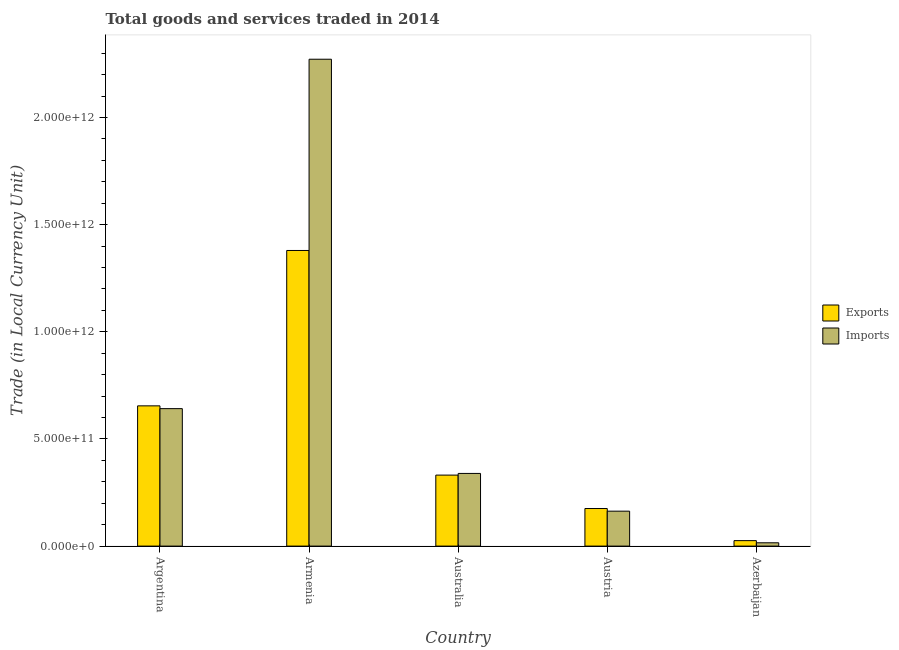How many groups of bars are there?
Ensure brevity in your answer.  5. Are the number of bars on each tick of the X-axis equal?
Keep it short and to the point. Yes. How many bars are there on the 3rd tick from the left?
Offer a terse response. 2. What is the label of the 2nd group of bars from the left?
Provide a succinct answer. Armenia. In how many cases, is the number of bars for a given country not equal to the number of legend labels?
Offer a very short reply. 0. What is the export of goods and services in Azerbaijan?
Your response must be concise. 2.55e+1. Across all countries, what is the maximum export of goods and services?
Your response must be concise. 1.38e+12. Across all countries, what is the minimum export of goods and services?
Your answer should be very brief. 2.55e+1. In which country was the imports of goods and services maximum?
Your answer should be very brief. Armenia. In which country was the export of goods and services minimum?
Your answer should be compact. Azerbaijan. What is the total imports of goods and services in the graph?
Provide a short and direct response. 3.43e+12. What is the difference between the export of goods and services in Armenia and that in Australia?
Your response must be concise. 1.05e+12. What is the difference between the export of goods and services in Australia and the imports of goods and services in Armenia?
Your answer should be very brief. -1.94e+12. What is the average imports of goods and services per country?
Ensure brevity in your answer.  6.86e+11. What is the difference between the export of goods and services and imports of goods and services in Argentina?
Offer a terse response. 1.30e+1. In how many countries, is the export of goods and services greater than 1500000000000 LCU?
Offer a terse response. 0. What is the ratio of the imports of goods and services in Armenia to that in Austria?
Provide a short and direct response. 13.94. Is the difference between the export of goods and services in Argentina and Australia greater than the difference between the imports of goods and services in Argentina and Australia?
Provide a short and direct response. Yes. What is the difference between the highest and the second highest export of goods and services?
Give a very brief answer. 7.25e+11. What is the difference between the highest and the lowest imports of goods and services?
Make the answer very short. 2.26e+12. In how many countries, is the imports of goods and services greater than the average imports of goods and services taken over all countries?
Make the answer very short. 1. What does the 2nd bar from the left in Australia represents?
Offer a terse response. Imports. What does the 1st bar from the right in Azerbaijan represents?
Give a very brief answer. Imports. How many countries are there in the graph?
Offer a terse response. 5. What is the difference between two consecutive major ticks on the Y-axis?
Offer a very short reply. 5.00e+11. Does the graph contain any zero values?
Provide a succinct answer. No. Does the graph contain grids?
Offer a terse response. No. Where does the legend appear in the graph?
Your response must be concise. Center right. What is the title of the graph?
Offer a terse response. Total goods and services traded in 2014. Does "% of GNI" appear as one of the legend labels in the graph?
Your answer should be very brief. No. What is the label or title of the X-axis?
Your answer should be very brief. Country. What is the label or title of the Y-axis?
Keep it short and to the point. Trade (in Local Currency Unit). What is the Trade (in Local Currency Unit) of Exports in Argentina?
Provide a short and direct response. 6.54e+11. What is the Trade (in Local Currency Unit) of Imports in Argentina?
Your answer should be very brief. 6.41e+11. What is the Trade (in Local Currency Unit) in Exports in Armenia?
Offer a very short reply. 1.38e+12. What is the Trade (in Local Currency Unit) of Imports in Armenia?
Your answer should be very brief. 2.27e+12. What is the Trade (in Local Currency Unit) in Exports in Australia?
Keep it short and to the point. 3.31e+11. What is the Trade (in Local Currency Unit) of Imports in Australia?
Your response must be concise. 3.39e+11. What is the Trade (in Local Currency Unit) of Exports in Austria?
Provide a short and direct response. 1.75e+11. What is the Trade (in Local Currency Unit) of Imports in Austria?
Ensure brevity in your answer.  1.63e+11. What is the Trade (in Local Currency Unit) in Exports in Azerbaijan?
Your answer should be very brief. 2.55e+1. What is the Trade (in Local Currency Unit) in Imports in Azerbaijan?
Your answer should be very brief. 1.55e+1. Across all countries, what is the maximum Trade (in Local Currency Unit) of Exports?
Offer a terse response. 1.38e+12. Across all countries, what is the maximum Trade (in Local Currency Unit) of Imports?
Keep it short and to the point. 2.27e+12. Across all countries, what is the minimum Trade (in Local Currency Unit) in Exports?
Your answer should be compact. 2.55e+1. Across all countries, what is the minimum Trade (in Local Currency Unit) in Imports?
Offer a very short reply. 1.55e+1. What is the total Trade (in Local Currency Unit) of Exports in the graph?
Offer a very short reply. 2.57e+12. What is the total Trade (in Local Currency Unit) of Imports in the graph?
Your response must be concise. 3.43e+12. What is the difference between the Trade (in Local Currency Unit) in Exports in Argentina and that in Armenia?
Provide a succinct answer. -7.25e+11. What is the difference between the Trade (in Local Currency Unit) in Imports in Argentina and that in Armenia?
Make the answer very short. -1.63e+12. What is the difference between the Trade (in Local Currency Unit) in Exports in Argentina and that in Australia?
Your answer should be very brief. 3.23e+11. What is the difference between the Trade (in Local Currency Unit) of Imports in Argentina and that in Australia?
Your answer should be very brief. 3.02e+11. What is the difference between the Trade (in Local Currency Unit) of Exports in Argentina and that in Austria?
Offer a terse response. 4.79e+11. What is the difference between the Trade (in Local Currency Unit) of Imports in Argentina and that in Austria?
Give a very brief answer. 4.78e+11. What is the difference between the Trade (in Local Currency Unit) of Exports in Argentina and that in Azerbaijan?
Keep it short and to the point. 6.29e+11. What is the difference between the Trade (in Local Currency Unit) of Imports in Argentina and that in Azerbaijan?
Provide a short and direct response. 6.26e+11. What is the difference between the Trade (in Local Currency Unit) of Exports in Armenia and that in Australia?
Give a very brief answer. 1.05e+12. What is the difference between the Trade (in Local Currency Unit) of Imports in Armenia and that in Australia?
Your answer should be very brief. 1.93e+12. What is the difference between the Trade (in Local Currency Unit) of Exports in Armenia and that in Austria?
Make the answer very short. 1.20e+12. What is the difference between the Trade (in Local Currency Unit) in Imports in Armenia and that in Austria?
Your answer should be compact. 2.11e+12. What is the difference between the Trade (in Local Currency Unit) in Exports in Armenia and that in Azerbaijan?
Offer a very short reply. 1.35e+12. What is the difference between the Trade (in Local Currency Unit) in Imports in Armenia and that in Azerbaijan?
Offer a terse response. 2.26e+12. What is the difference between the Trade (in Local Currency Unit) of Exports in Australia and that in Austria?
Your answer should be compact. 1.56e+11. What is the difference between the Trade (in Local Currency Unit) of Imports in Australia and that in Austria?
Provide a succinct answer. 1.76e+11. What is the difference between the Trade (in Local Currency Unit) in Exports in Australia and that in Azerbaijan?
Keep it short and to the point. 3.06e+11. What is the difference between the Trade (in Local Currency Unit) in Imports in Australia and that in Azerbaijan?
Keep it short and to the point. 3.24e+11. What is the difference between the Trade (in Local Currency Unit) in Exports in Austria and that in Azerbaijan?
Your answer should be compact. 1.50e+11. What is the difference between the Trade (in Local Currency Unit) in Imports in Austria and that in Azerbaijan?
Make the answer very short. 1.48e+11. What is the difference between the Trade (in Local Currency Unit) in Exports in Argentina and the Trade (in Local Currency Unit) in Imports in Armenia?
Give a very brief answer. -1.62e+12. What is the difference between the Trade (in Local Currency Unit) of Exports in Argentina and the Trade (in Local Currency Unit) of Imports in Australia?
Your answer should be very brief. 3.15e+11. What is the difference between the Trade (in Local Currency Unit) in Exports in Argentina and the Trade (in Local Currency Unit) in Imports in Austria?
Your answer should be compact. 4.91e+11. What is the difference between the Trade (in Local Currency Unit) in Exports in Argentina and the Trade (in Local Currency Unit) in Imports in Azerbaijan?
Offer a terse response. 6.39e+11. What is the difference between the Trade (in Local Currency Unit) of Exports in Armenia and the Trade (in Local Currency Unit) of Imports in Australia?
Give a very brief answer. 1.04e+12. What is the difference between the Trade (in Local Currency Unit) in Exports in Armenia and the Trade (in Local Currency Unit) in Imports in Austria?
Your response must be concise. 1.22e+12. What is the difference between the Trade (in Local Currency Unit) in Exports in Armenia and the Trade (in Local Currency Unit) in Imports in Azerbaijan?
Keep it short and to the point. 1.36e+12. What is the difference between the Trade (in Local Currency Unit) of Exports in Australia and the Trade (in Local Currency Unit) of Imports in Austria?
Your answer should be very brief. 1.68e+11. What is the difference between the Trade (in Local Currency Unit) of Exports in Australia and the Trade (in Local Currency Unit) of Imports in Azerbaijan?
Your answer should be compact. 3.16e+11. What is the difference between the Trade (in Local Currency Unit) in Exports in Austria and the Trade (in Local Currency Unit) in Imports in Azerbaijan?
Make the answer very short. 1.60e+11. What is the average Trade (in Local Currency Unit) of Exports per country?
Give a very brief answer. 5.13e+11. What is the average Trade (in Local Currency Unit) in Imports per country?
Make the answer very short. 6.86e+11. What is the difference between the Trade (in Local Currency Unit) of Exports and Trade (in Local Currency Unit) of Imports in Argentina?
Your answer should be very brief. 1.30e+1. What is the difference between the Trade (in Local Currency Unit) in Exports and Trade (in Local Currency Unit) in Imports in Armenia?
Offer a terse response. -8.92e+11. What is the difference between the Trade (in Local Currency Unit) of Exports and Trade (in Local Currency Unit) of Imports in Australia?
Provide a succinct answer. -7.82e+09. What is the difference between the Trade (in Local Currency Unit) in Exports and Trade (in Local Currency Unit) in Imports in Austria?
Provide a succinct answer. 1.24e+1. What is the difference between the Trade (in Local Currency Unit) of Exports and Trade (in Local Currency Unit) of Imports in Azerbaijan?
Your answer should be very brief. 1.01e+1. What is the ratio of the Trade (in Local Currency Unit) of Exports in Argentina to that in Armenia?
Give a very brief answer. 0.47. What is the ratio of the Trade (in Local Currency Unit) of Imports in Argentina to that in Armenia?
Offer a terse response. 0.28. What is the ratio of the Trade (in Local Currency Unit) in Exports in Argentina to that in Australia?
Your response must be concise. 1.98. What is the ratio of the Trade (in Local Currency Unit) in Imports in Argentina to that in Australia?
Make the answer very short. 1.89. What is the ratio of the Trade (in Local Currency Unit) in Exports in Argentina to that in Austria?
Offer a terse response. 3.73. What is the ratio of the Trade (in Local Currency Unit) of Imports in Argentina to that in Austria?
Offer a very short reply. 3.94. What is the ratio of the Trade (in Local Currency Unit) of Exports in Argentina to that in Azerbaijan?
Your answer should be compact. 25.63. What is the ratio of the Trade (in Local Currency Unit) in Imports in Argentina to that in Azerbaijan?
Keep it short and to the point. 41.47. What is the ratio of the Trade (in Local Currency Unit) of Exports in Armenia to that in Australia?
Make the answer very short. 4.16. What is the ratio of the Trade (in Local Currency Unit) of Imports in Armenia to that in Australia?
Your answer should be very brief. 6.7. What is the ratio of the Trade (in Local Currency Unit) of Exports in Armenia to that in Austria?
Your answer should be very brief. 7.87. What is the ratio of the Trade (in Local Currency Unit) of Imports in Armenia to that in Austria?
Give a very brief answer. 13.94. What is the ratio of the Trade (in Local Currency Unit) in Exports in Armenia to that in Azerbaijan?
Give a very brief answer. 54.03. What is the ratio of the Trade (in Local Currency Unit) of Imports in Armenia to that in Azerbaijan?
Your response must be concise. 146.89. What is the ratio of the Trade (in Local Currency Unit) in Exports in Australia to that in Austria?
Keep it short and to the point. 1.89. What is the ratio of the Trade (in Local Currency Unit) in Imports in Australia to that in Austria?
Make the answer very short. 2.08. What is the ratio of the Trade (in Local Currency Unit) in Exports in Australia to that in Azerbaijan?
Provide a short and direct response. 12.97. What is the ratio of the Trade (in Local Currency Unit) in Imports in Australia to that in Azerbaijan?
Your answer should be very brief. 21.92. What is the ratio of the Trade (in Local Currency Unit) of Exports in Austria to that in Azerbaijan?
Your answer should be compact. 6.87. What is the ratio of the Trade (in Local Currency Unit) in Imports in Austria to that in Azerbaijan?
Provide a short and direct response. 10.54. What is the difference between the highest and the second highest Trade (in Local Currency Unit) of Exports?
Your response must be concise. 7.25e+11. What is the difference between the highest and the second highest Trade (in Local Currency Unit) in Imports?
Give a very brief answer. 1.63e+12. What is the difference between the highest and the lowest Trade (in Local Currency Unit) in Exports?
Provide a short and direct response. 1.35e+12. What is the difference between the highest and the lowest Trade (in Local Currency Unit) in Imports?
Make the answer very short. 2.26e+12. 